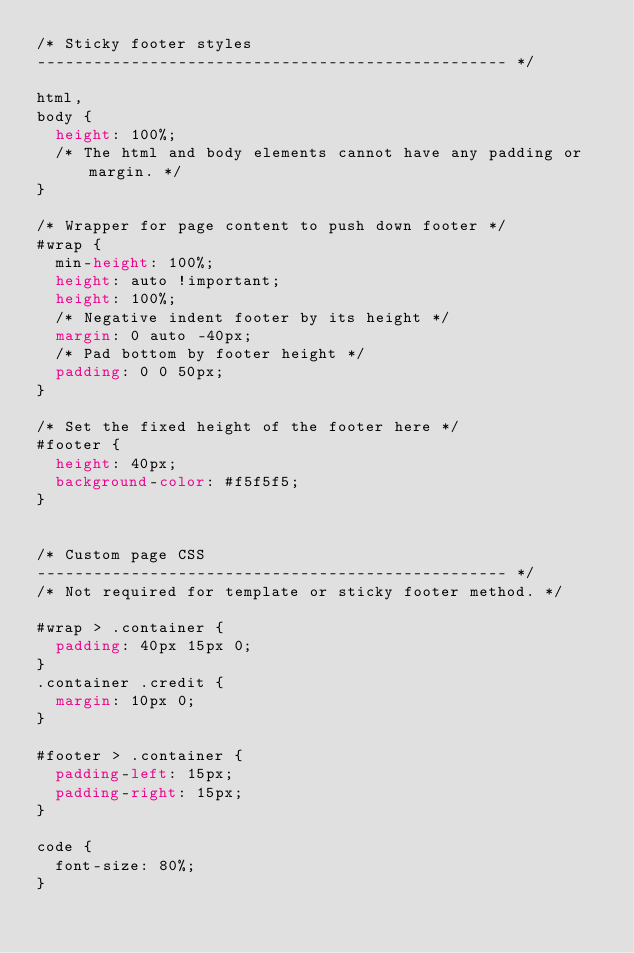Convert code to text. <code><loc_0><loc_0><loc_500><loc_500><_CSS_>/* Sticky footer styles
-------------------------------------------------- */

html,
body {
  height: 100%;
  /* The html and body elements cannot have any padding or margin. */
}

/* Wrapper for page content to push down footer */
#wrap {
  min-height: 100%;
  height: auto !important;
  height: 100%;
  /* Negative indent footer by its height */
  margin: 0 auto -40px;
  /* Pad bottom by footer height */
  padding: 0 0 50px;
}

/* Set the fixed height of the footer here */
#footer {
  height: 40px;
  background-color: #f5f5f5;
}


/* Custom page CSS
-------------------------------------------------- */
/* Not required for template or sticky footer method. */

#wrap > .container {
  padding: 40px 15px 0;
}
.container .credit {
  margin: 10px 0;
}

#footer > .container {
  padding-left: 15px;
  padding-right: 15px;
}

code {
  font-size: 80%;
}
</code> 